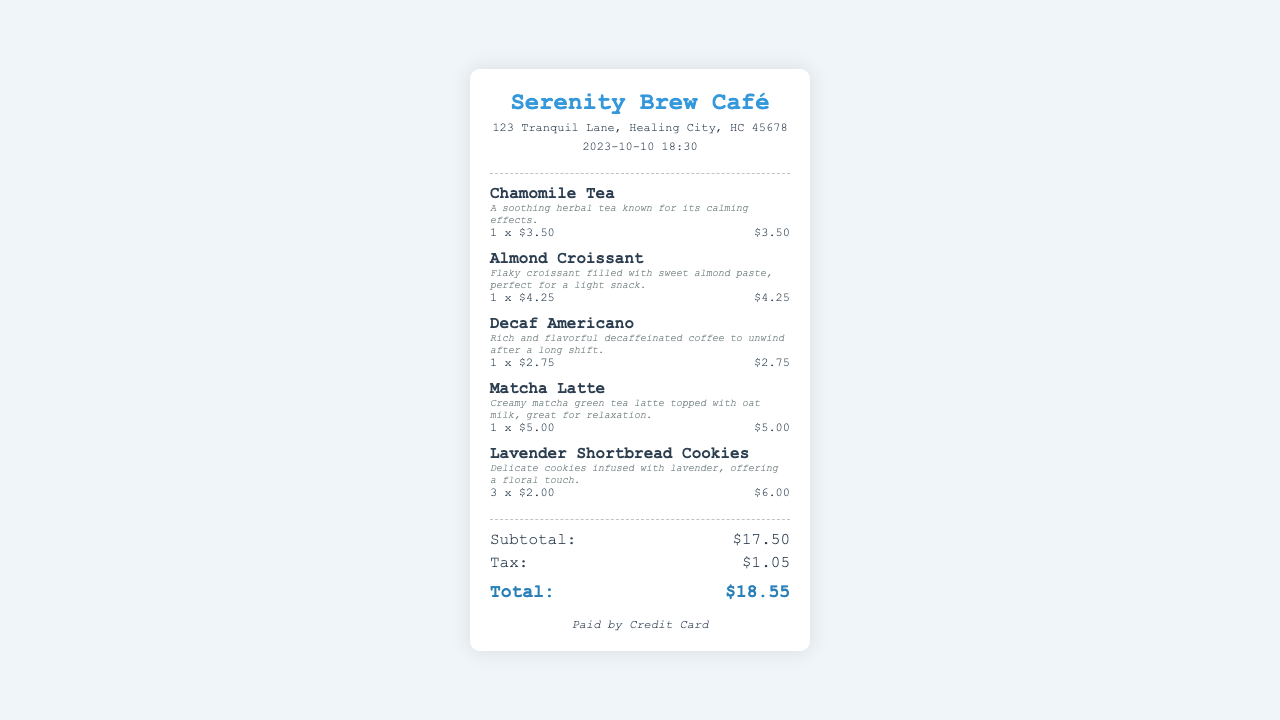What is the name of the café? The café's name is located at the top of the receipt.
Answer: Serenity Brew Café What date and time is the receipt from? The receipt displays the date and time at the top.
Answer: 2023-10-10 18:30 How much is the subtotal? The subtotal is specified in the totals section of the receipt.
Answer: $17.50 What is the cost of the Lavender Shortbread Cookies? The price for the Lavender Shortbread Cookies is detailed in the items list.
Answer: $6.00 How many items were purchased in total? The total number of items can be determined by counting each line in the items section.
Answer: 5 What is the payment method used? The payment method is stated at the bottom of the receipt.
Answer: Credit Card What is the price of the Decaf Americano? The price for the Decaf Americano is shown next to the item description.
Answer: $2.75 What type of tea is included in the order? The order includes a specific type of tea mentioned in the items list.
Answer: Chamomile Tea What is the total amount paid? The total amount is listed at the end of the totals section.
Answer: $18.55 